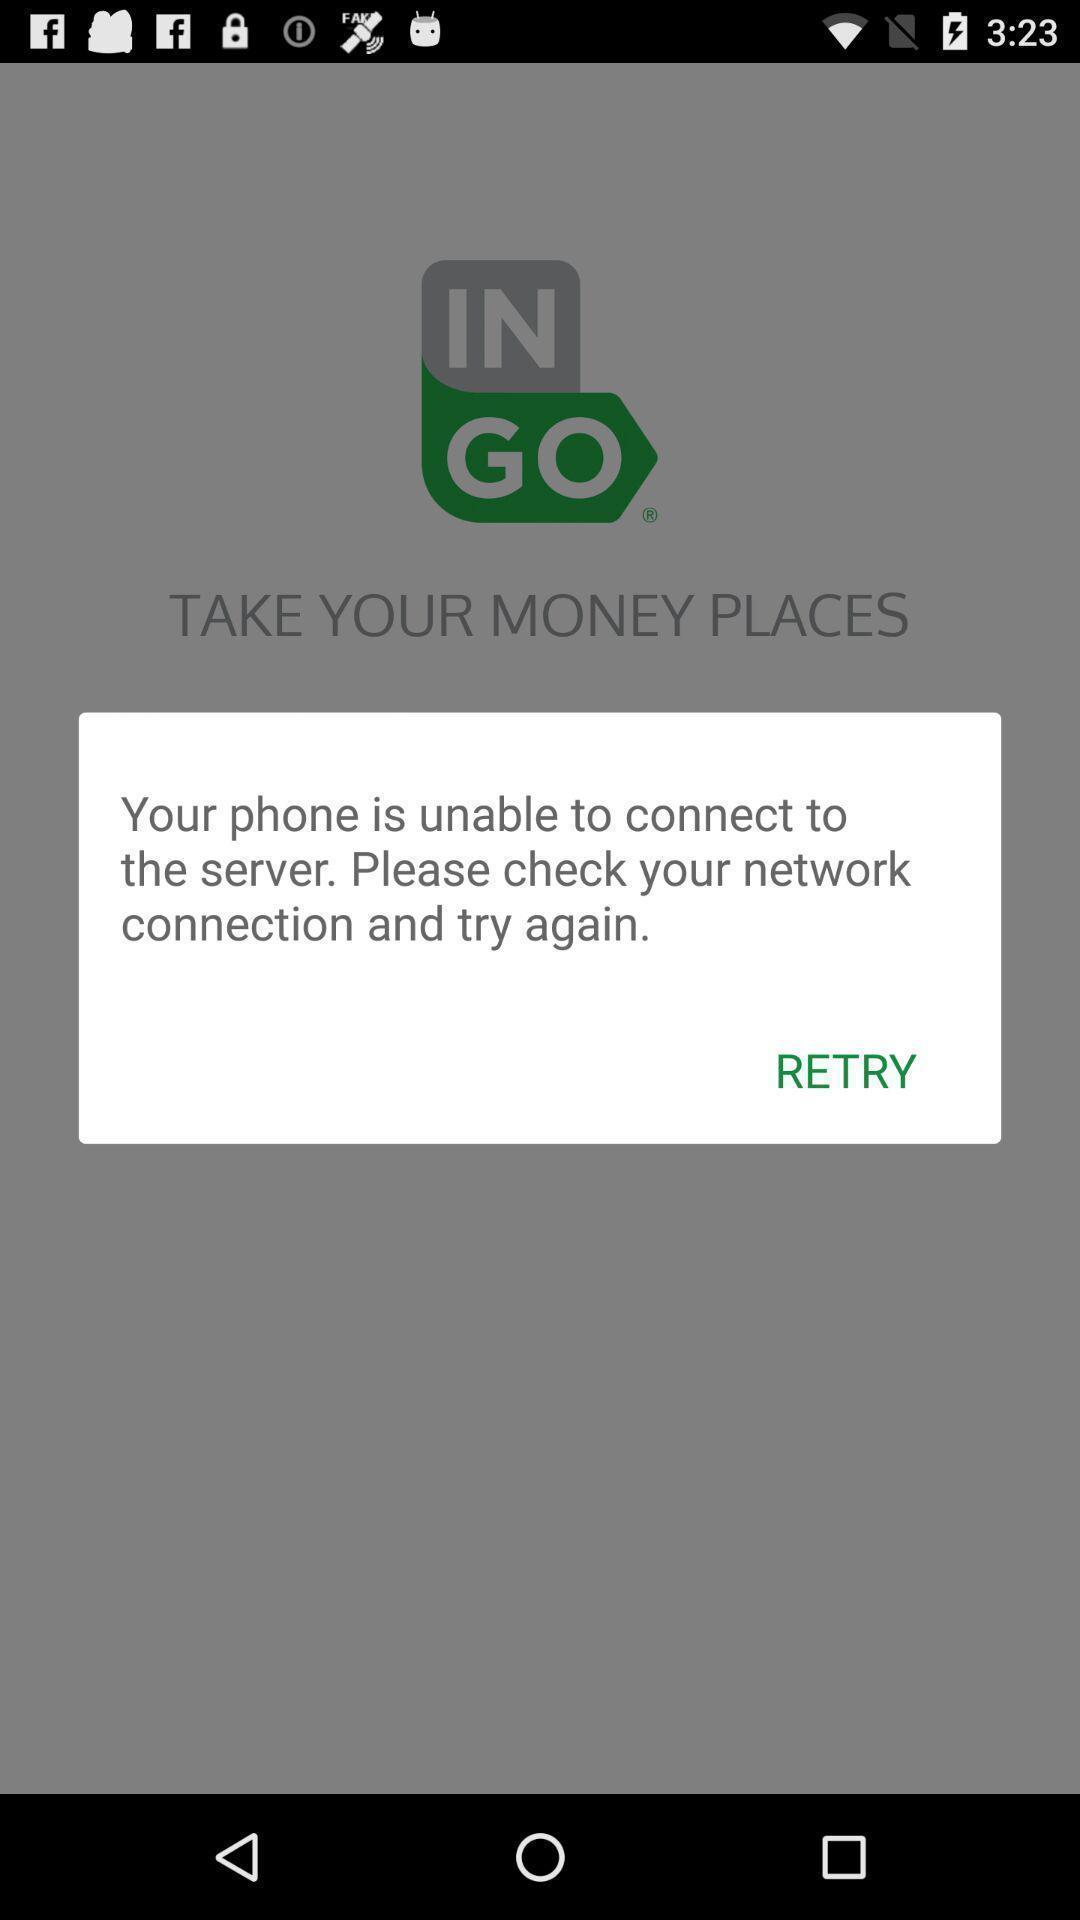Provide a detailed account of this screenshot. Popup to retry the page in the payment app. 